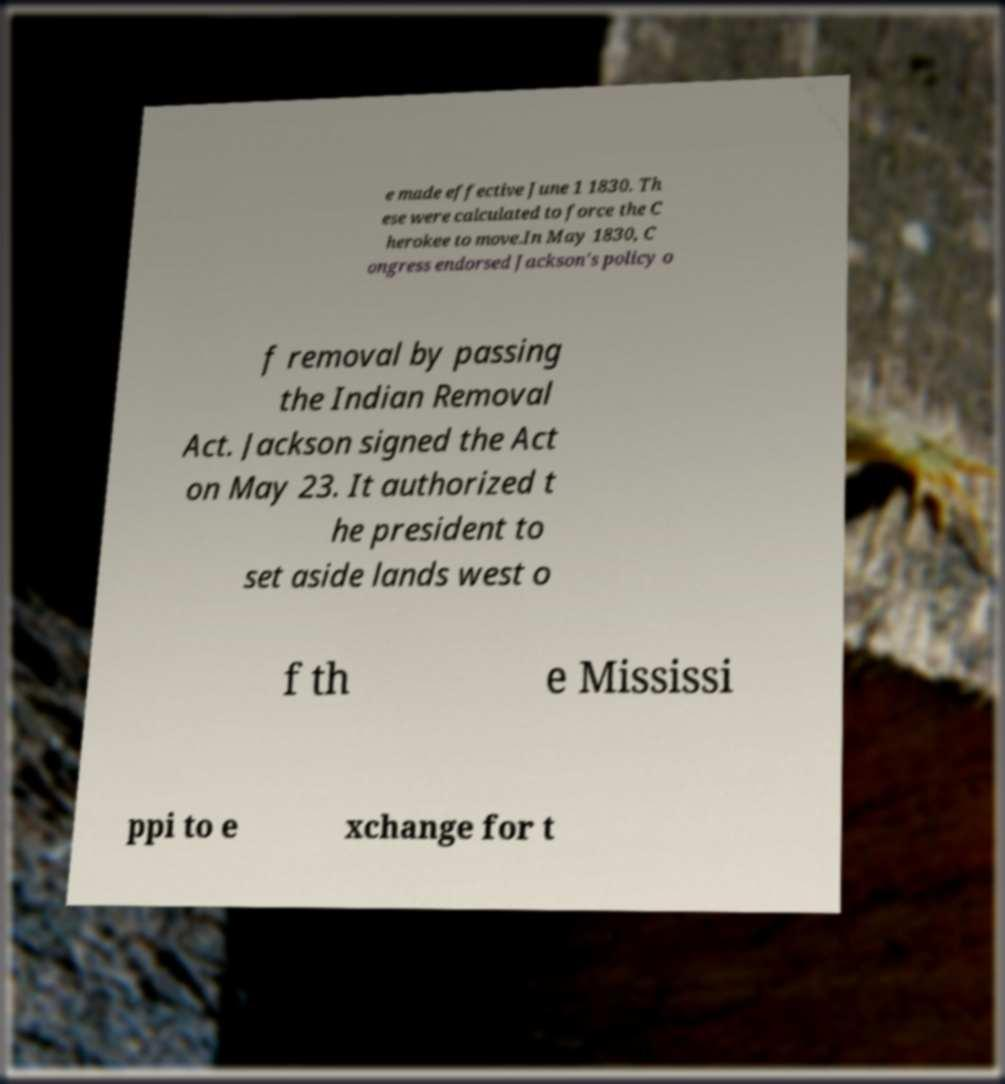Could you assist in decoding the text presented in this image and type it out clearly? e made effective June 1 1830. Th ese were calculated to force the C herokee to move.In May 1830, C ongress endorsed Jackson's policy o f removal by passing the Indian Removal Act. Jackson signed the Act on May 23. It authorized t he president to set aside lands west o f th e Mississi ppi to e xchange for t 